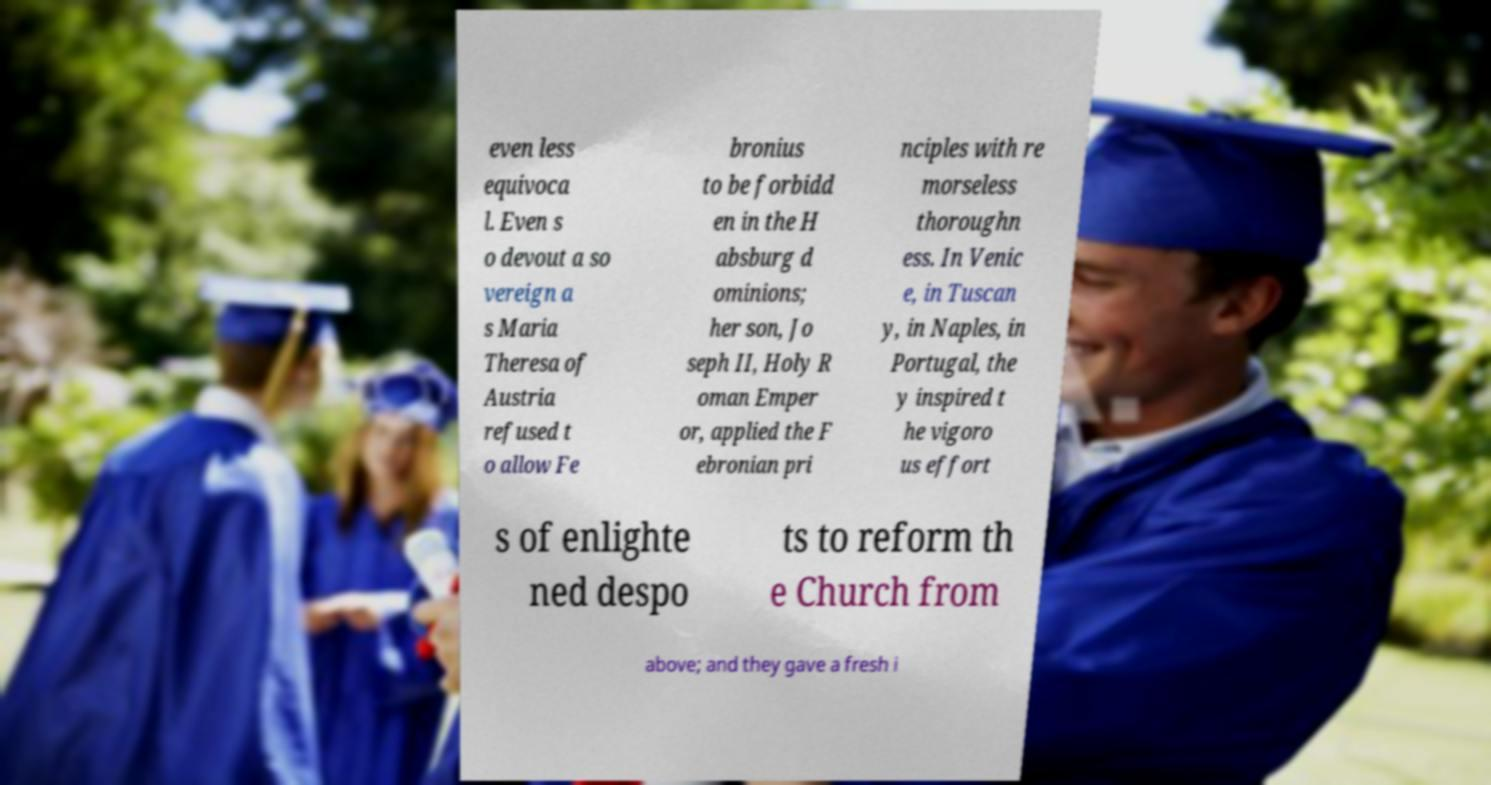Please read and relay the text visible in this image. What does it say? even less equivoca l. Even s o devout a so vereign a s Maria Theresa of Austria refused t o allow Fe bronius to be forbidd en in the H absburg d ominions; her son, Jo seph II, Holy R oman Emper or, applied the F ebronian pri nciples with re morseless thoroughn ess. In Venic e, in Tuscan y, in Naples, in Portugal, the y inspired t he vigoro us effort s of enlighte ned despo ts to reform th e Church from above; and they gave a fresh i 